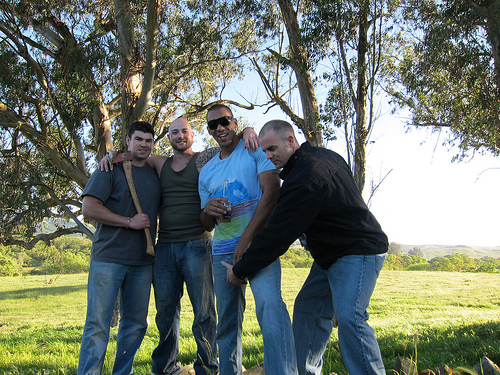<image>
Is there a man next to the man? Yes. The man is positioned adjacent to the man, located nearby in the same general area. 